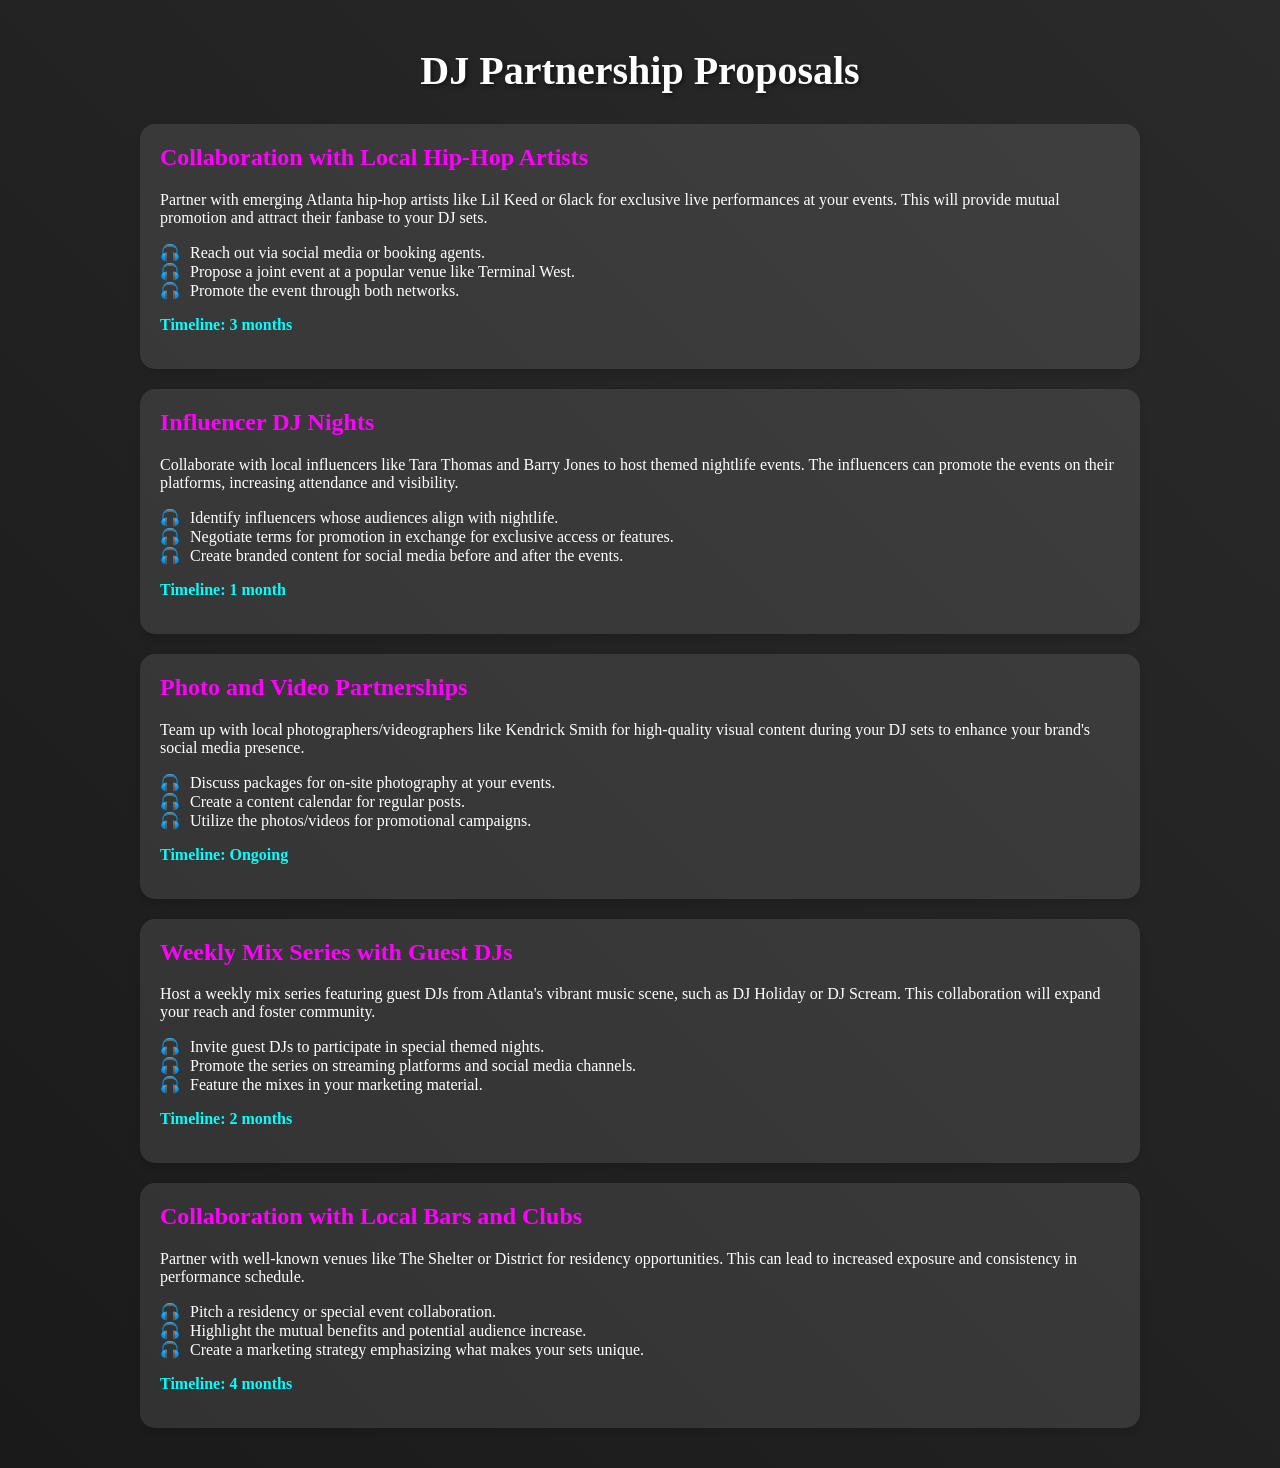What is the first collaboration proposal mentioned? The first collaboration proposal is with local hip-hop artists for exclusive live performances.
Answer: Collaboration with Local Hip-Hop Artists How long is the timeline for the Influencer DJ Nights proposal? The Influencer DJ Nights proposal has a timeline of 1 month.
Answer: 1 month Which local venue is suggested for a pitch regarding collaboration? The document mentions The Shelter or District as potential venues for collaboration.
Answer: The Shelter or District Who is the photographer recommended for partnerships? Kendrick Smith is mentioned as a local photographer/videographer for partnerships.
Answer: Kendrick Smith What is one of the strategies listed for promoting the Weekly Mix Series? One strategy listed is to promote the series on streaming platforms and social media channels.
Answer: Promote on streaming platforms What is the timeline for collaborating with local bars and clubs? The timeline for collaborating with local bars and clubs is 4 months.
Answer: 4 months What is the mutual benefit highlighted in the collaboration with bars and clubs? Increased exposure and consistency in performance schedule is highlighted as a mutual benefit.
Answer: Increased exposure What involvement is suggested from local influencers in the nightlife events? Local influencers are suggested to promote the events on their platforms.
Answer: Promote on their platforms What type of content is to be created from the photo and video partnerships? The content created will enhance the brand's social media presence.
Answer: Enhance social media presence 